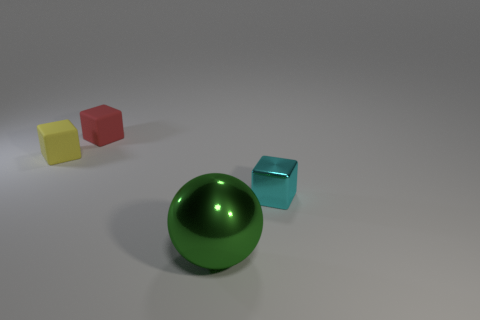Add 3 green things. How many objects exist? 7 Subtract all tiny metallic blocks. How many blocks are left? 2 Subtract 1 cubes. How many cubes are left? 2 Subtract all spheres. How many objects are left? 3 Subtract 0 yellow cylinders. How many objects are left? 4 Subtract all purple cubes. Subtract all brown balls. How many cubes are left? 3 Subtract all tiny shiny things. Subtract all tiny green objects. How many objects are left? 3 Add 2 metal things. How many metal things are left? 4 Add 3 big green shiny spheres. How many big green shiny spheres exist? 4 